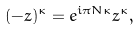Convert formula to latex. <formula><loc_0><loc_0><loc_500><loc_500>( - z ) ^ { \kappa } = e ^ { i \pi N \kappa } z ^ { \kappa } ,</formula> 